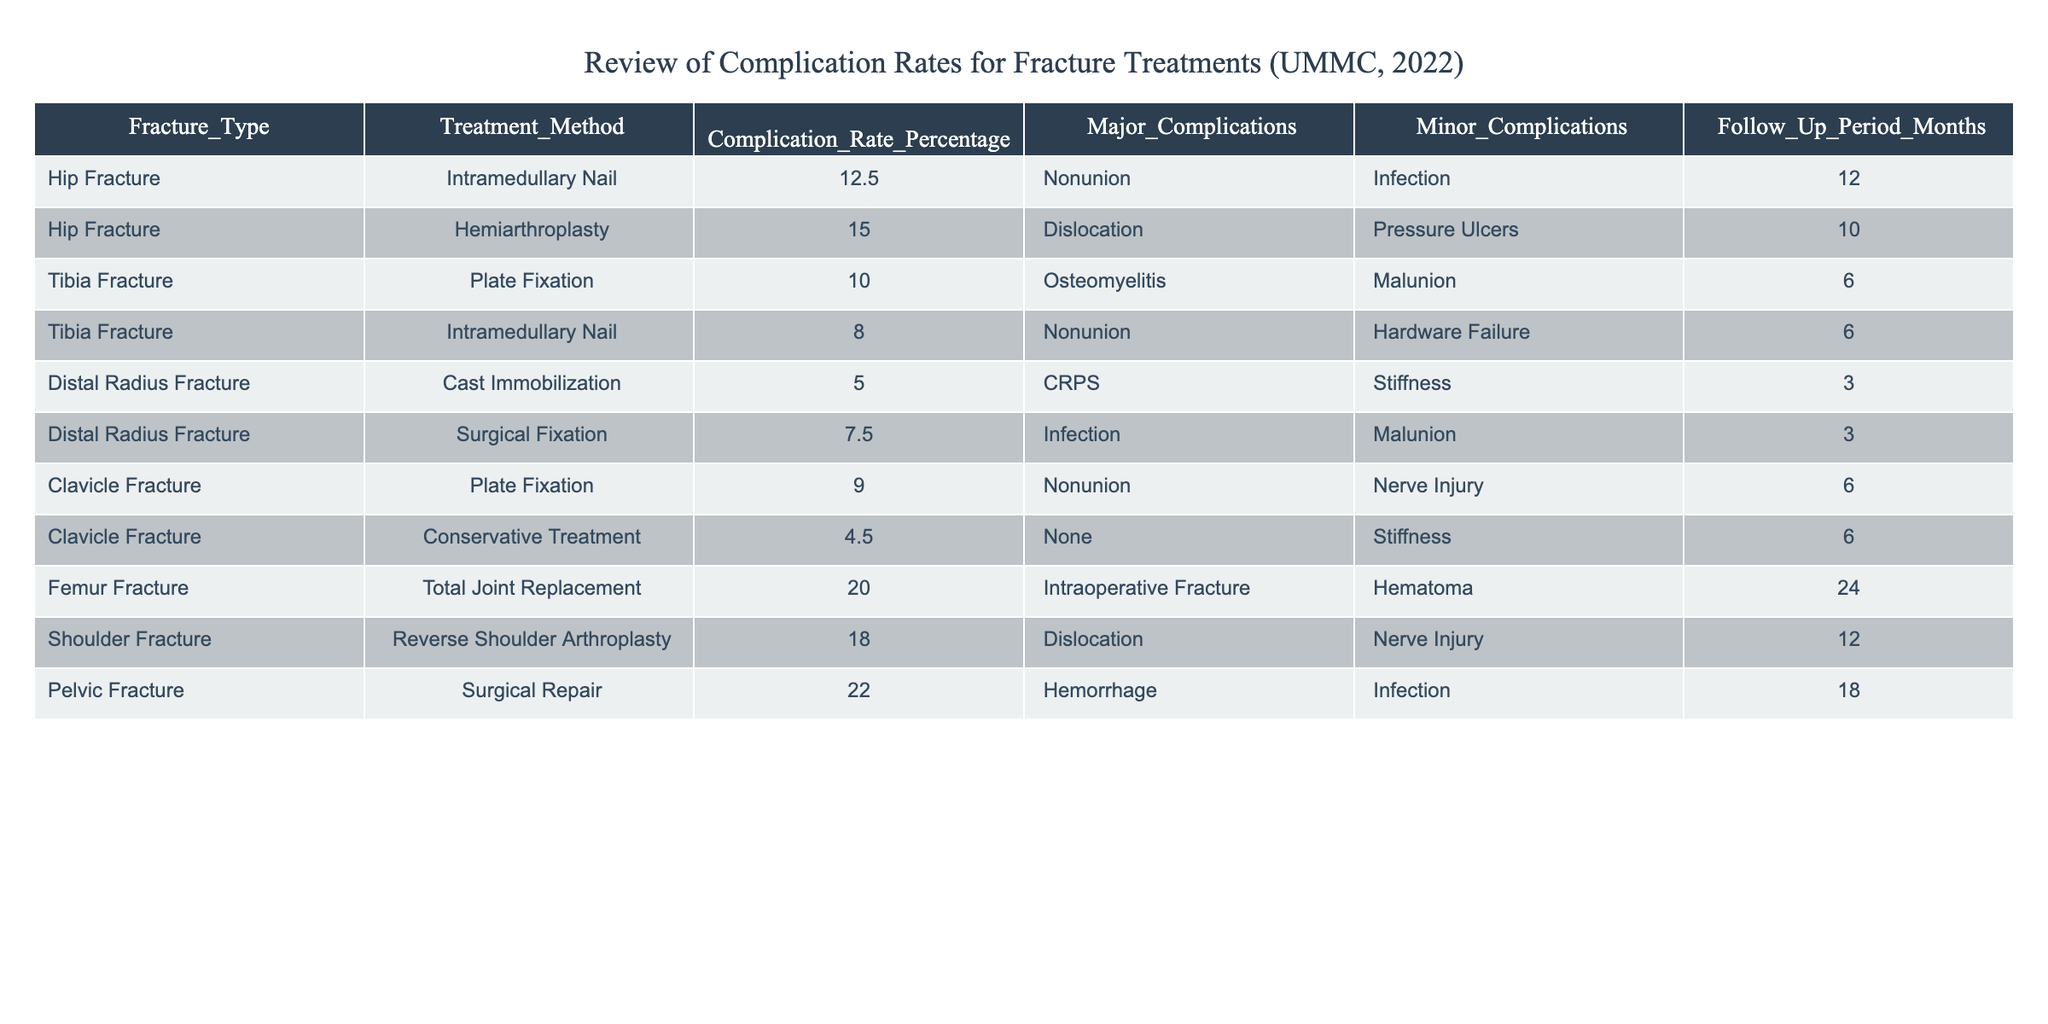What is the complication rate for Hemiarthroplasty in hip fractures? The complication rate for Hemiarthroplasty is listed in the table under the corresponding Treatment Method for Hip Fracture. It shows a value of 15.0%.
Answer: 15.0% Which fracture treatment method has the highest complication rate? The table lists all treatment methods along with their complication rates. By comparing the rates, Surgical Repair for Pelvic Fracture has the highest rate at 22.0%.
Answer: 22.0% What is the average complication rate for all treatments of Tibia Fractures? The complication rates for Tibia Fractures are 10.0% (Plate Fixation) and 8.0% (Intramedullary Nail). The average is calculated as (10.0 + 8.0) / 2 = 9.0%.
Answer: 9.0% Are there any treatments listed with a complication rate lower than 5%? By scanning the complication rates in the table, it is evident that all listed treatment methods have rates above 5%, confirming that no treatments fall below that threshold.
Answer: No What percentage of major complications is associated with Surgical Fixation for Distal Radius Fracture? The table specifies the major complications associated with Surgical Fixation for Distal Radius Fracture as Infection, which is noted but not quantified in percentage. The complication rate overall is 7.5%, which does not differentiate between major and minor complications.
Answer: 7.5% For which treatment method is the follow-up period the longest, and how long is it? In the table, the follow-up periods are outlined. The treatment method with the longest follow-up period is Total Joint Replacement for Femur Fracture, which has a follow-up of 24 months.
Answer: 24 months What is the total number of major complications recorded across all treatments? By reviewing the table, we identify the major complications listed for each treatment: Nonunion, Dislocation, Osteomyelitis, Nonunion, None, Nonunion, Intraoperative Fracture, Dislocation, Hemorrhage. Counting these gives us a total of 9 instances, with some treatments having the same complication.
Answer: 9 Is there a treatment that has both major and minor complications? The table shows that several treatments report both major and minor complications. For instance, Intramedullary Nail for Hip Fracture has Nonunion as a major and Infection as a minor complication.
Answer: Yes What is the difference in complication rates between Cast Immobilization and Surgical Fixation for Distal Radius Fractures? The complication rate for Cast Immobilization is 5.0%, and for Surgical Fixation, it is 7.5%. The difference can be calculated as 7.5% - 5.0% = 2.5%.
Answer: 2.5% Is the complication rate for Conservative Treatment of Clavicle Fractures above or below 5%? The complication rate for Conservative Treatment is listed in the table as 4.5%, which is below the 5% mark.
Answer: Below 5% Which treatment method was associated with multiple major complications? Upon reviewing the table, Pelvic Fracture Surgical Repair presents with Hemorrhage and Infection as major complications, therefore associating it with multiple major complications.
Answer: Surgical Repair for Pelvic Fracture 